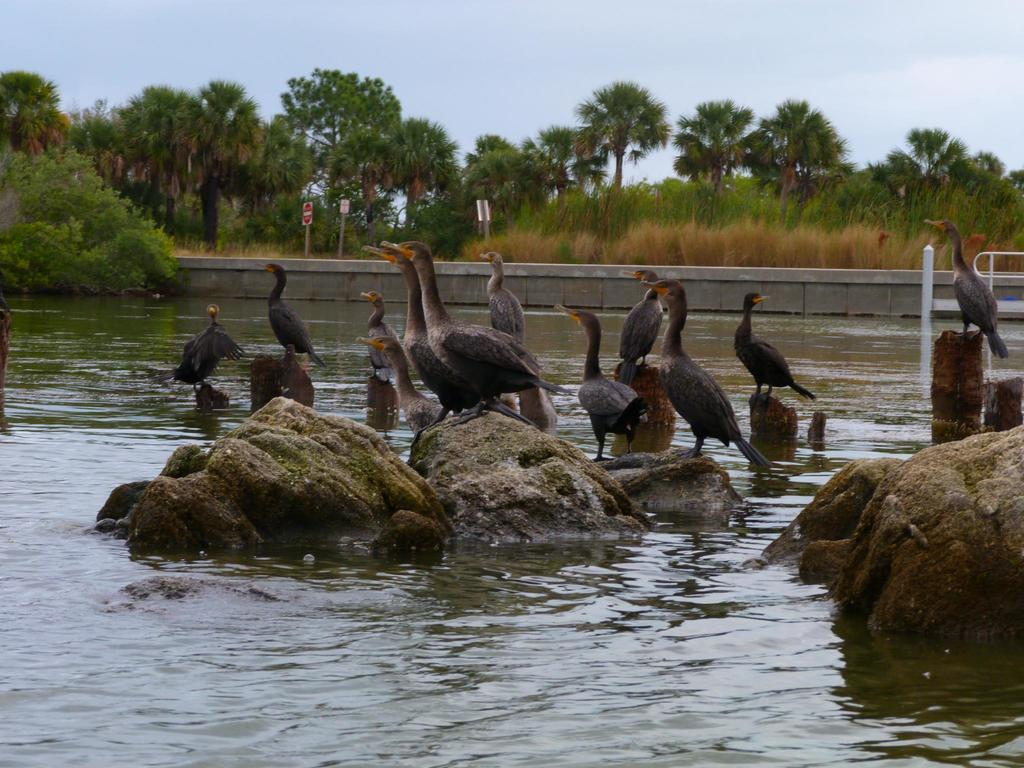What type of animals can be seen in the image? There are birds in the image. What are the birds standing on? The birds are standing on stones. What is the color scheme of the birds in the image? The birds are in black and white color. What is visible in the background of the image? There is water, trees, and signboards visible in the image. What is the color of the sky in the image? The sky is blue and white in color. How many apples can be seen hanging from the trees in the image? There are no apples visible in the image; the trees are not mentioned to have any fruit. What type of carriage is present in the image? There is no carriage present in the image. 